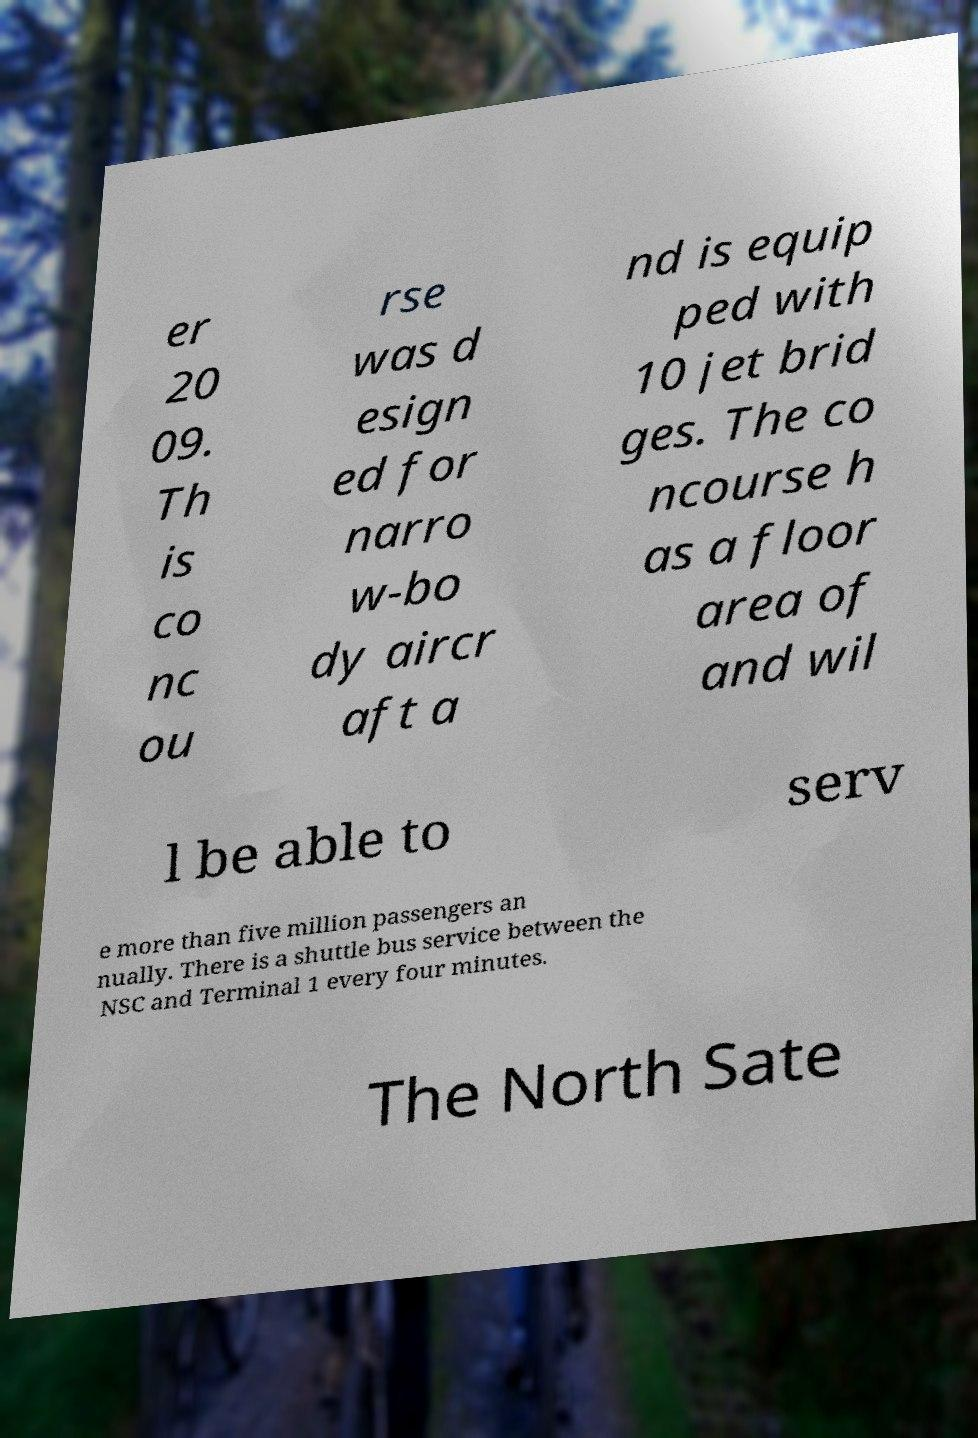I need the written content from this picture converted into text. Can you do that? er 20 09. Th is co nc ou rse was d esign ed for narro w-bo dy aircr aft a nd is equip ped with 10 jet brid ges. The co ncourse h as a floor area of and wil l be able to serv e more than five million passengers an nually. There is a shuttle bus service between the NSC and Terminal 1 every four minutes. The North Sate 